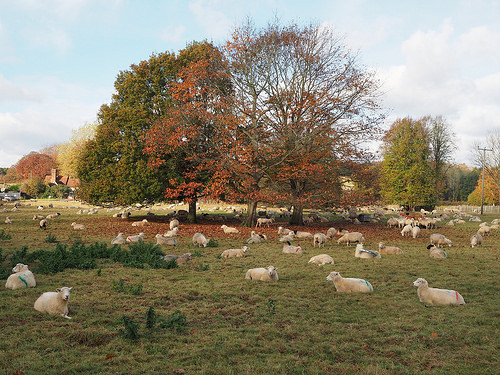<image>
Is the sheep behind the sheep? No. The sheep is not behind the sheep. From this viewpoint, the sheep appears to be positioned elsewhere in the scene. 